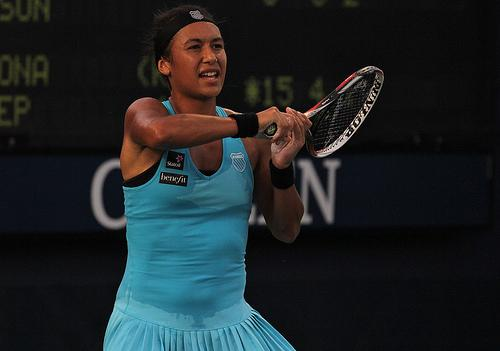Offer a concise summary of the main individual's appearance and what they are doing in the image. A lady in a blue tennis dress and black accessories plays the sport, holding a red and black tennis racket in her hands. Give a short account of the main object in the image and what it is engaged in. A female tennis player clad in blue is captured playing the sport with a red and black racket and wearing a black headband. Provide a brief description of the central figure in the image and their actions. A woman dressed in blue plays tennis, holding a red and black racket while wearing a black headband and wristband. Mention the primary character and their ongoing activity in the image. The image showcases a female tennis player in a blue outfit, actively engaging in a game with her red and black racket. Identify the leading character in the image and describe their activity. The image features a woman in a blue tennis outfit, participating in a match using a red and black racket, and donning a black headband. Present a snapshot of the principal person in the image and their occupation. A lady in a blue tennis dress is the focus of the image, playing tennis with a red and black racket and adorned with a black headband. Portray the main figure in the image and explain their engagement. In this image, a female tennis player in a blue outfit actively competes, sporting a black headband and grasping a red and black racket. Explain the picture's focus by highlighting the central person and their current task. In the image, a woman dressed in blue tennis attire is playing the game, wielding a red and black racket and wearing a black headband. Narrate the essence of the image by focusing on the primary subject and their action. A tennis player dressed in blue, with a black headband and wristband, skillfully handles a red and black racket during a match. Illustrate the central character's presence and involvement in the picture. The image displays a woman in blue tennis attire, wielding a red and black racket, engaging in the sport while wearing a black headband. 